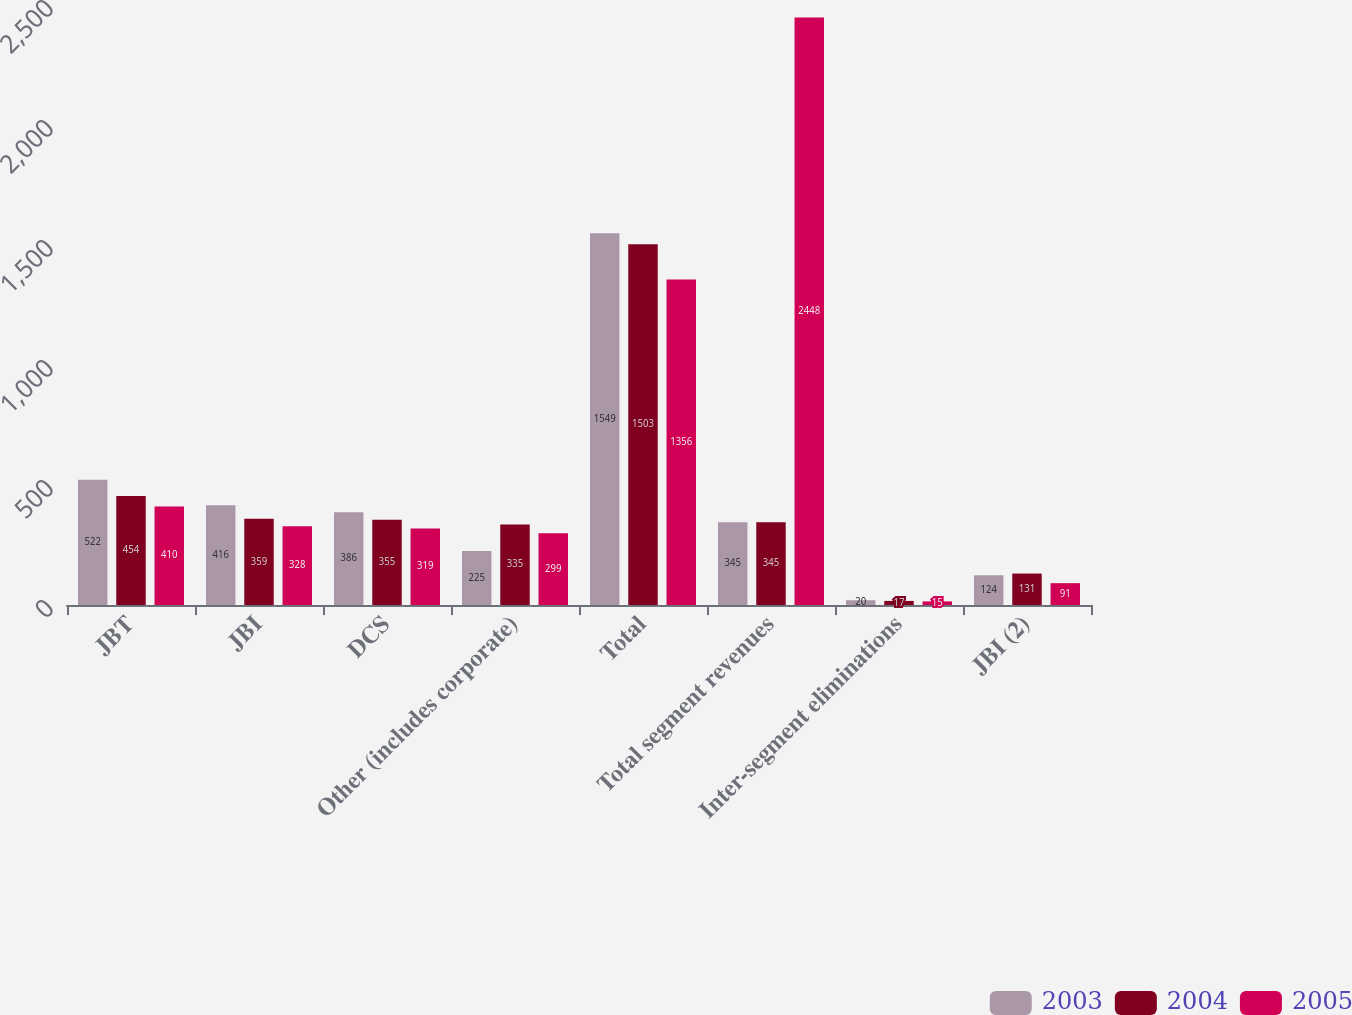Convert chart to OTSL. <chart><loc_0><loc_0><loc_500><loc_500><stacked_bar_chart><ecel><fcel>JBT<fcel>JBI<fcel>DCS<fcel>Other (includes corporate)<fcel>Total<fcel>Total segment revenues<fcel>Inter-segment eliminations<fcel>JBI (2)<nl><fcel>2003<fcel>522<fcel>416<fcel>386<fcel>225<fcel>1549<fcel>345<fcel>20<fcel>124<nl><fcel>2004<fcel>454<fcel>359<fcel>355<fcel>335<fcel>1503<fcel>345<fcel>17<fcel>131<nl><fcel>2005<fcel>410<fcel>328<fcel>319<fcel>299<fcel>1356<fcel>2448<fcel>15<fcel>91<nl></chart> 